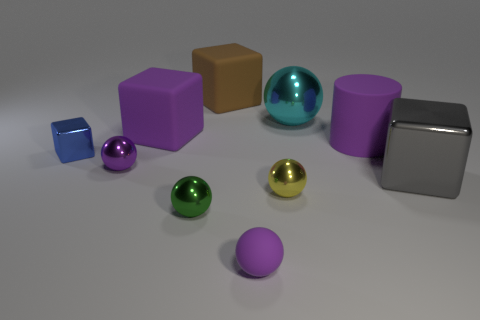How many other blue blocks have the same material as the small blue block?
Provide a short and direct response. 0. Does the purple sphere left of the purple cube have the same material as the big cyan object that is on the right side of the tiny green sphere?
Offer a terse response. Yes. How many big purple blocks are right of the cube that is right of the large rubber cylinder that is in front of the brown rubber object?
Give a very brief answer. 0. Does the rubber object that is in front of the big purple matte cylinder have the same color as the big matte cube on the left side of the brown thing?
Your answer should be compact. Yes. Are there any other things of the same color as the small metal block?
Your answer should be compact. No. The cube that is in front of the tiny shiny sphere to the left of the green metallic sphere is what color?
Provide a short and direct response. Gray. Are any brown shiny objects visible?
Ensure brevity in your answer.  No. What is the color of the shiny thing that is behind the purple metallic sphere and to the right of the purple rubber sphere?
Make the answer very short. Cyan. There is a shiny ball behind the small blue object; does it have the same size as the matte thing in front of the large gray metallic cube?
Your answer should be very brief. No. How many other things are there of the same size as the purple metallic ball?
Provide a short and direct response. 4. 